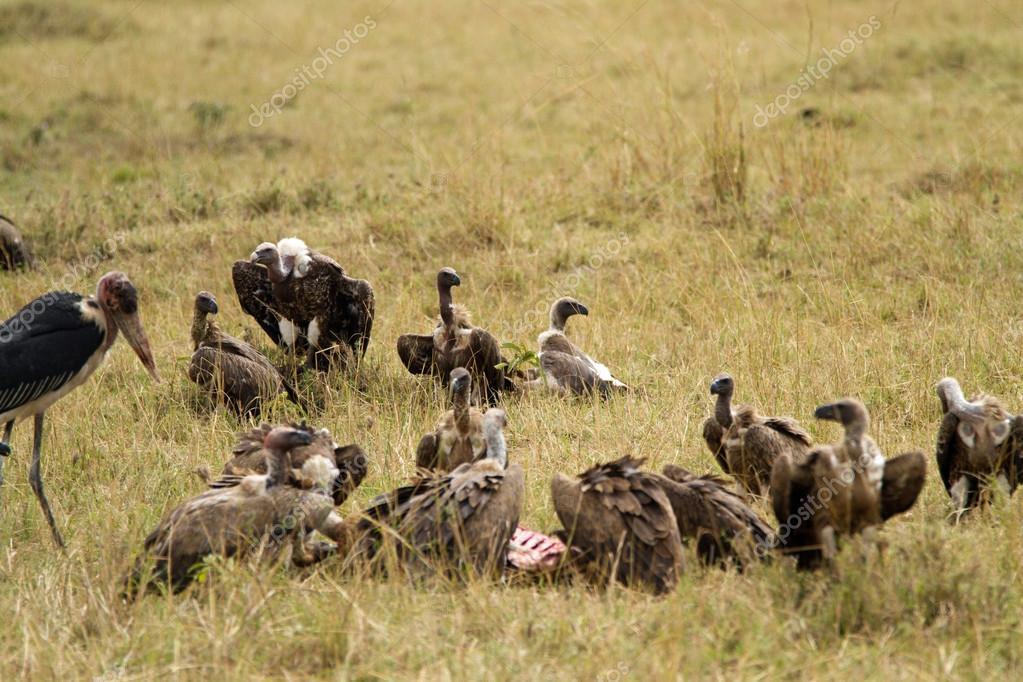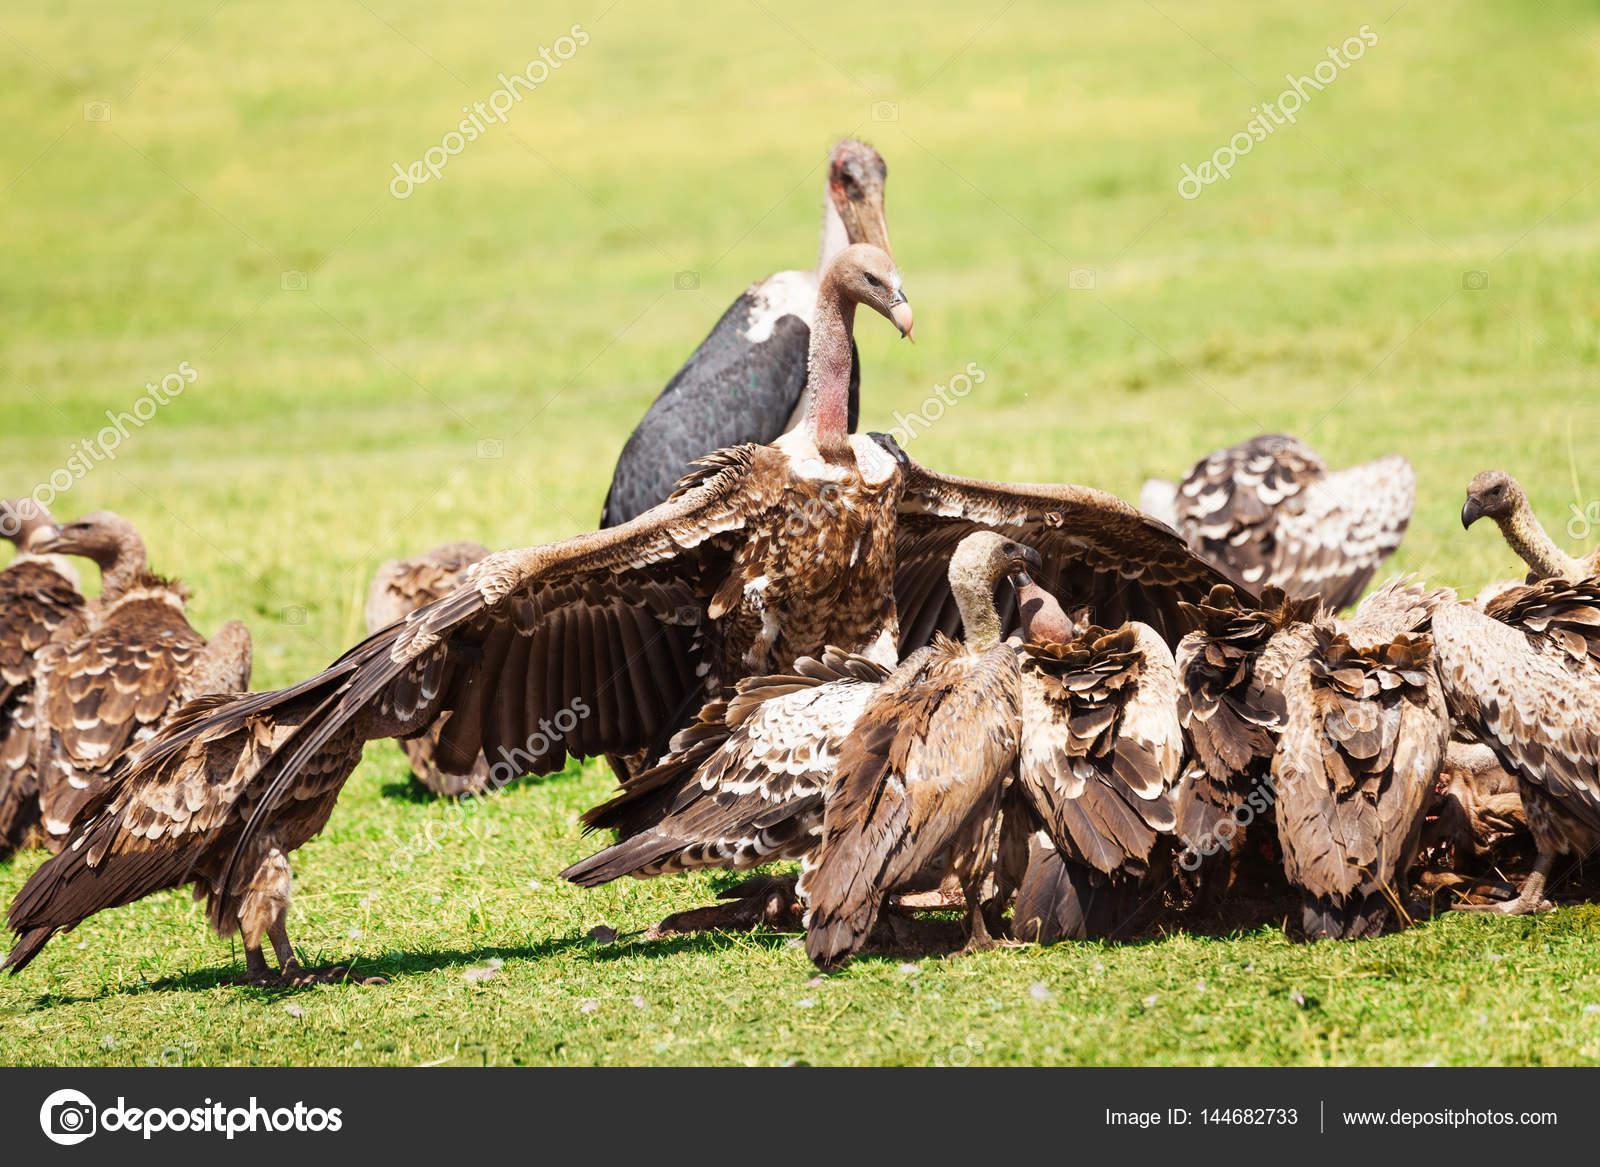The first image is the image on the left, the second image is the image on the right. Examine the images to the left and right. Is the description "None of the birds have outstretched wings in the image on the left." accurate? Answer yes or no. Yes. 